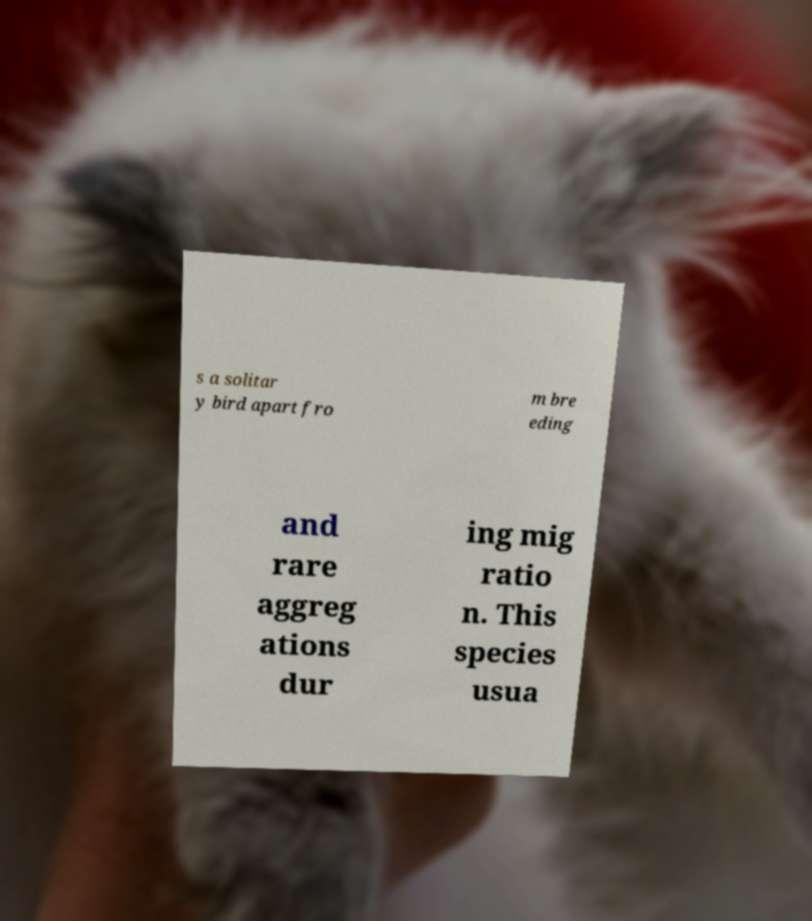For documentation purposes, I need the text within this image transcribed. Could you provide that? s a solitar y bird apart fro m bre eding and rare aggreg ations dur ing mig ratio n. This species usua 